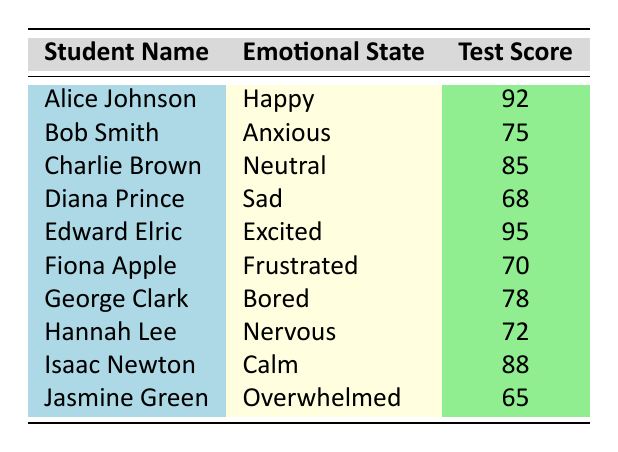What is the highest test score recorded in the table? Looking through the "Test Score" column, I see that the highest score is 95, which belongs to Edward Elric.
Answer: 95 What emotional state did Jasmine Green report? Referring to the row corresponding to Jasmine Green, her emotional state is listed as "Overwhelmed."
Answer: Overwhelmed How many students scored above 80? Looking at the "Test Score" column, the students with scores above 80 are Alice Johnson (92), Charlie Brown (85), Edward Elric (95), and Isaac Newton (88). This totals 4 students.
Answer: 4 What is the average test score of students in a "Sad" emotional state? The only student in a "Sad" emotional state is Diana Prince, who scored 68. Since there is only one student, the average is simply 68.
Answer: 68 Did any student scored below 70? In the "Test Score" column, I see that both Diana Prince (68) and Jasmine Green (65) scored below 70, which confirms that at least one student did.
Answer: Yes Which emotional state corresponds to the second-lowest test score? The second-lowest test score in the table is 70, which corresponds to Fiona Apple, who reported being "Frustrated."
Answer: Frustrated What is the difference between the highest and lowest test scores? The highest test score is 95 (Edward Elric) and the lowest test score is 65 (Jasmine Green). Therefore, the difference is 95 - 65 = 30.
Answer: 30 How many students are in an "Anxious" emotional state and what was their average score? Bob Smith is the only student who is "Anxious" with a score of 75. Since there is only one student, the average score is also 75.
Answer: 75 Which emotional state has the highest average score? To find this, calculate the average score for each emotional state: "Happy" (92), "Anxious" (75), "Neutral" (85), "Sad" (68), "Excited" (95), "Frustrated" (70), "Bored" (78), "Nervous" (72), "Calm" (88), "Overwhelmed" (65). The highest average score is from the "Excited" state (95).
Answer: Excited 